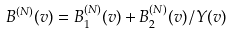Convert formula to latex. <formula><loc_0><loc_0><loc_500><loc_500>B ^ { ( N ) } ( v ) = B _ { 1 } ^ { ( N ) } ( v ) + B _ { 2 } ^ { ( N ) } ( v ) / Y ( v )</formula> 